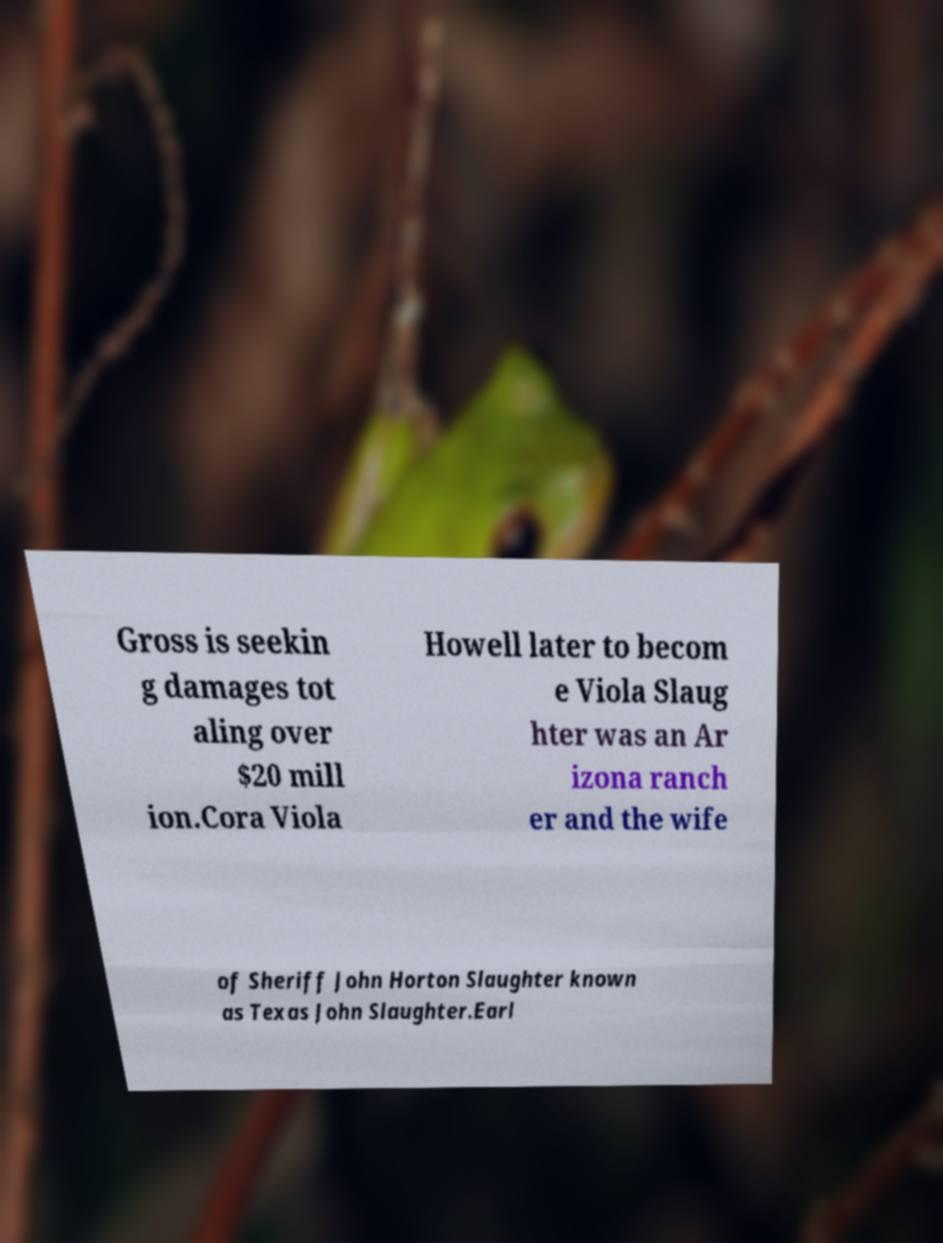Please read and relay the text visible in this image. What does it say? Gross is seekin g damages tot aling over $20 mill ion.Cora Viola Howell later to becom e Viola Slaug hter was an Ar izona ranch er and the wife of Sheriff John Horton Slaughter known as Texas John Slaughter.Earl 